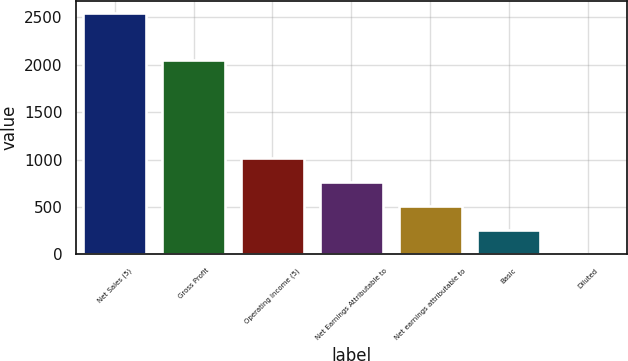Convert chart. <chart><loc_0><loc_0><loc_500><loc_500><bar_chart><fcel>Net Sales (5)<fcel>Gross Profit<fcel>Operating Income (5)<fcel>Net Earnings Attributable to<fcel>Net earnings attributable to<fcel>Basic<fcel>Diluted<nl><fcel>2549.8<fcel>2051.1<fcel>1020.21<fcel>765.27<fcel>510.33<fcel>255.39<fcel>0.45<nl></chart> 